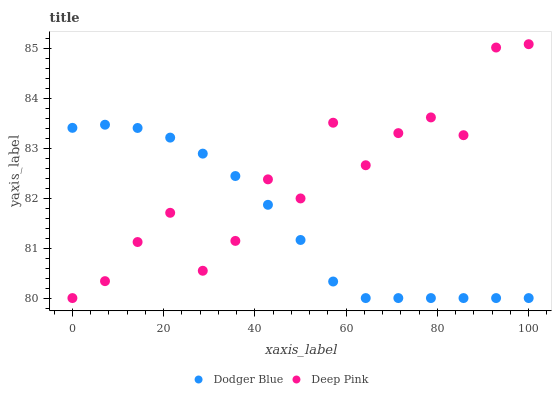Does Dodger Blue have the minimum area under the curve?
Answer yes or no. Yes. Does Deep Pink have the maximum area under the curve?
Answer yes or no. Yes. Does Dodger Blue have the maximum area under the curve?
Answer yes or no. No. Is Dodger Blue the smoothest?
Answer yes or no. Yes. Is Deep Pink the roughest?
Answer yes or no. Yes. Is Dodger Blue the roughest?
Answer yes or no. No. Does Deep Pink have the lowest value?
Answer yes or no. Yes. Does Deep Pink have the highest value?
Answer yes or no. Yes. Does Dodger Blue have the highest value?
Answer yes or no. No. Does Dodger Blue intersect Deep Pink?
Answer yes or no. Yes. Is Dodger Blue less than Deep Pink?
Answer yes or no. No. Is Dodger Blue greater than Deep Pink?
Answer yes or no. No. 